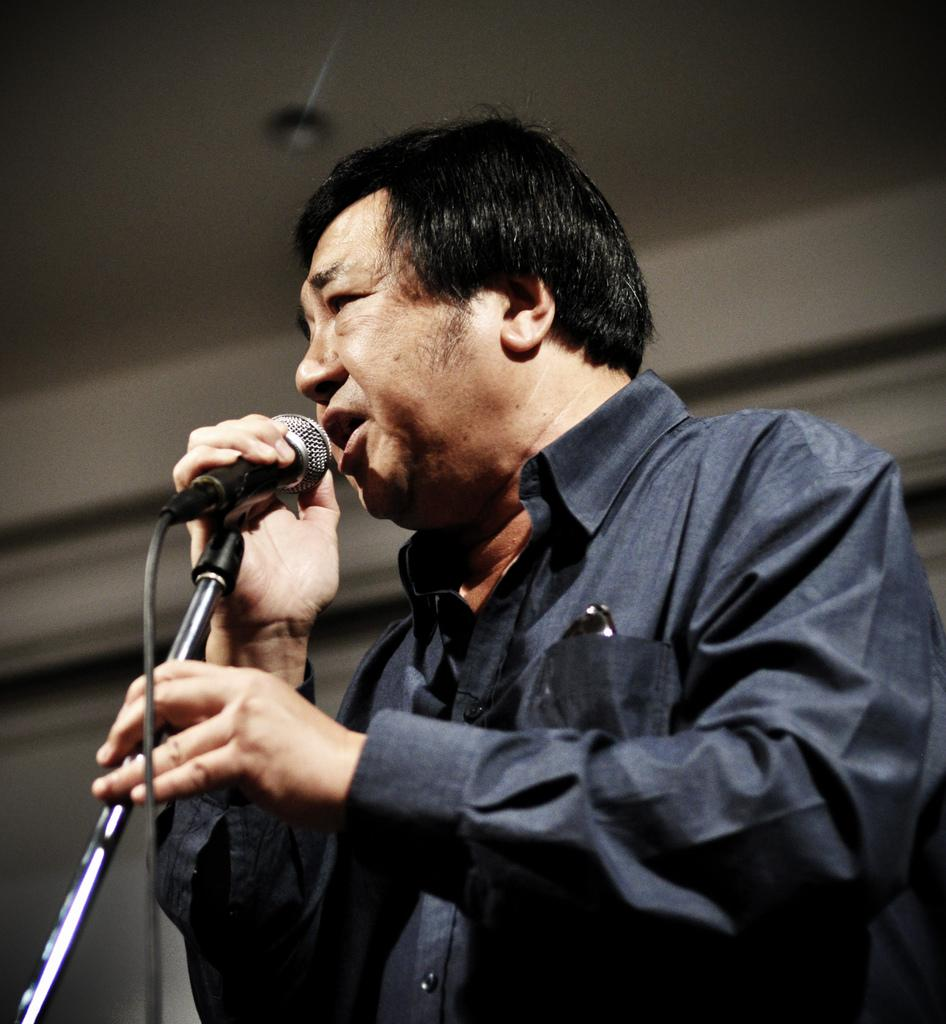What is the main subject of the image? The main subject of the image is a man. What is the man doing in the image? The man is singing in the image. What object is the man holding in his hand? The man is holding a microphone in his hand. Are there any giants visible in the image? No, there are no giants present in the image. What is the weight of the microphone the man is holding? The weight of the microphone cannot be determined from the image alone. 